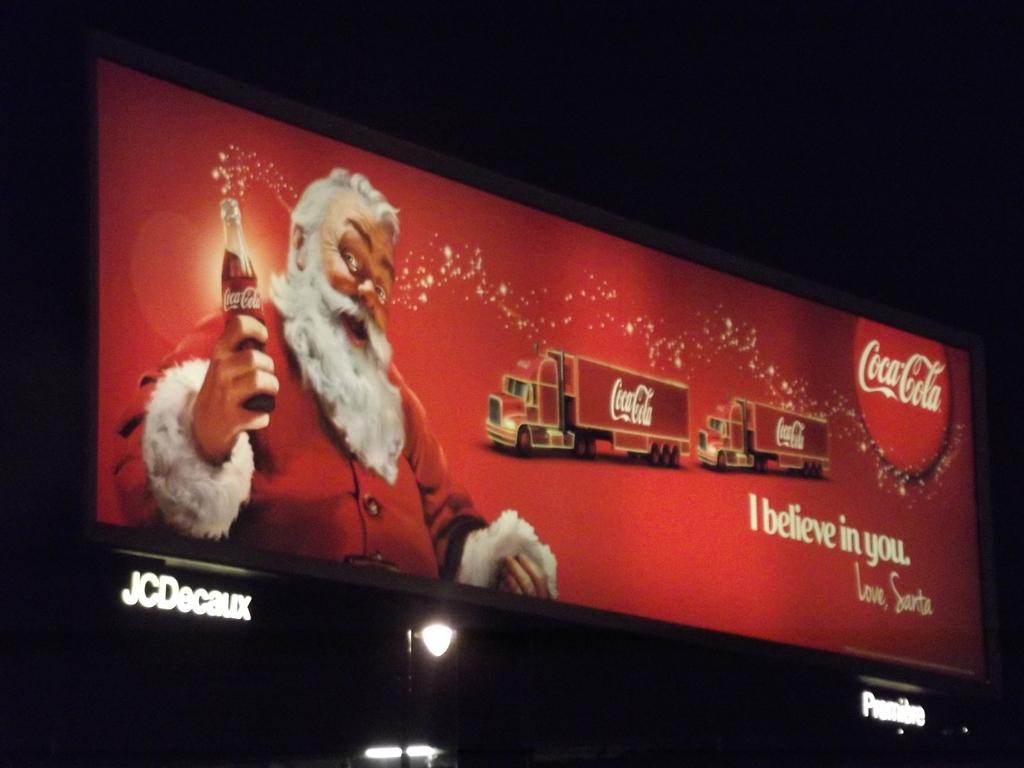Whose product is santa promoting?
Keep it short and to the point. Coca cola. 